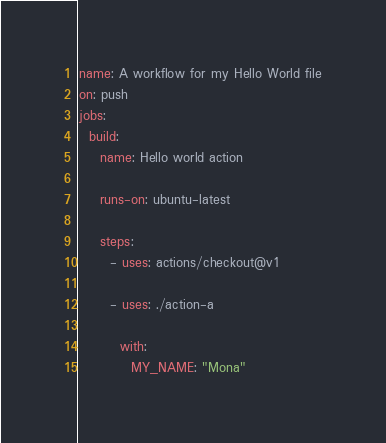Convert code to text. <code><loc_0><loc_0><loc_500><loc_500><_YAML_>name: A workflow for my Hello World file
on: push
jobs:
  build:
    name: Hello world action

    runs-on: ubuntu-latest

    steps:
      - uses: actions/checkout@v1

      - uses: ./action-a

        with:
          MY_NAME: "Mona"
</code> 